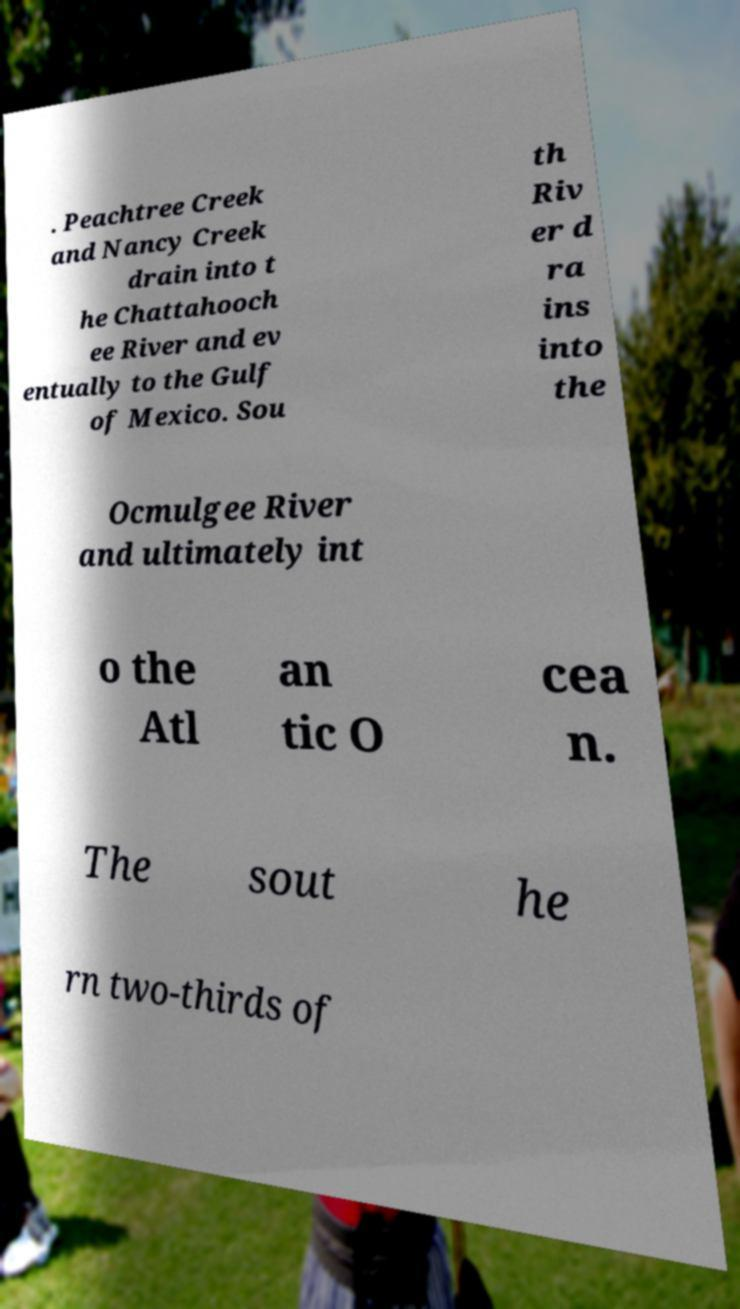Please read and relay the text visible in this image. What does it say? . Peachtree Creek and Nancy Creek drain into t he Chattahooch ee River and ev entually to the Gulf of Mexico. Sou th Riv er d ra ins into the Ocmulgee River and ultimately int o the Atl an tic O cea n. The sout he rn two-thirds of 